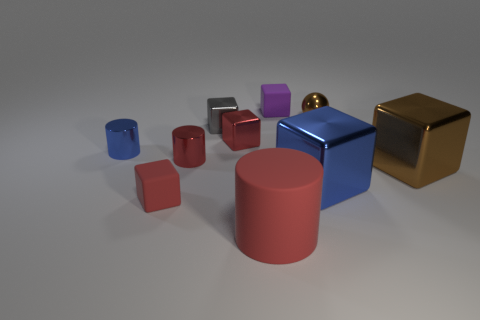Describe the lighting in this scene. Where do you think the light source might be located? The scene is softly lit with diffused shadows suggesting an overhead light source, possibly out of frame. The gentle light doesn't create harsh shadows, giving a calm and even illumination to the objects, and the reflections on the shiny surfaces further hint towards the light being above. 